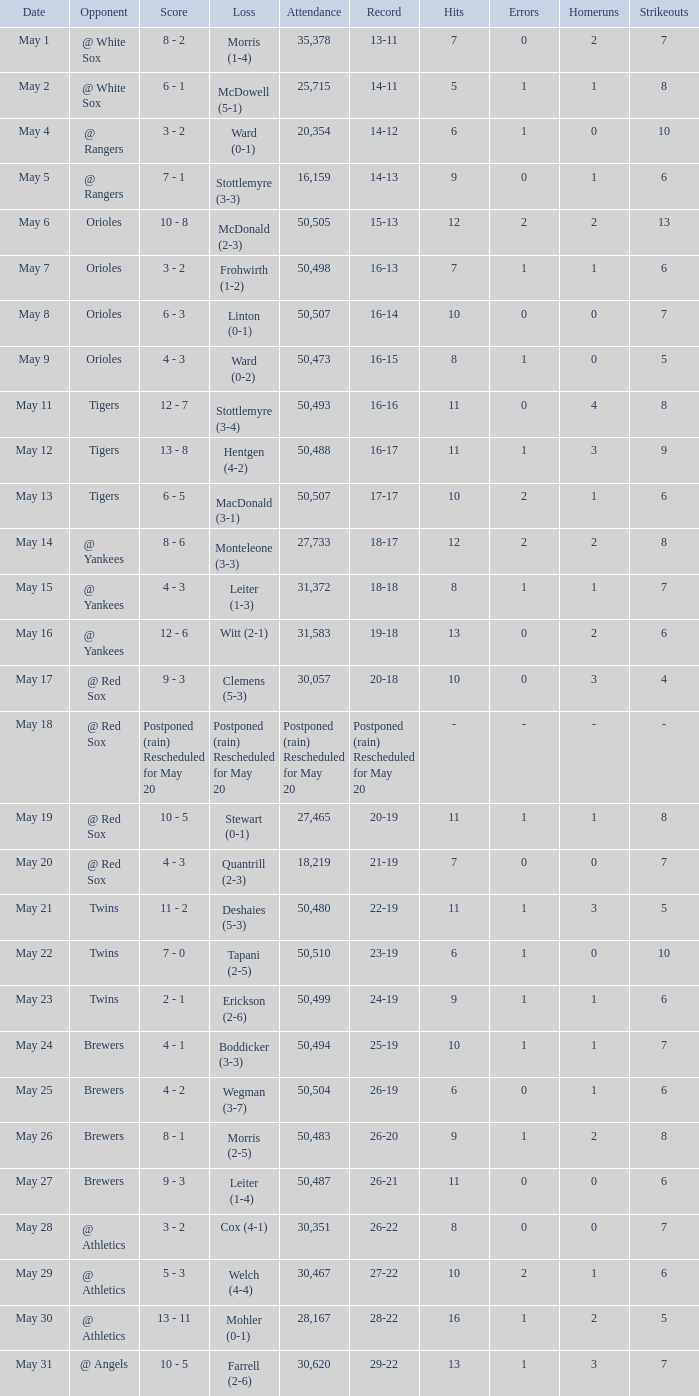On May 29 which team had the loss? Welch (4-4). 